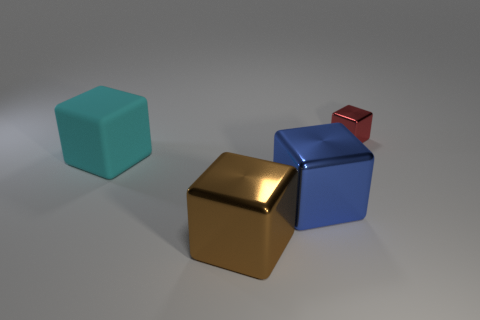Subtract all large cyan rubber blocks. How many blocks are left? 3 Add 4 big cyan cubes. How many objects exist? 8 Subtract all red blocks. How many blocks are left? 3 Subtract all purple cubes. Subtract all purple balls. How many cubes are left? 4 Subtract 0 cyan spheres. How many objects are left? 4 Subtract all yellow matte cylinders. Subtract all small red metallic objects. How many objects are left? 3 Add 3 blue shiny things. How many blue shiny things are left? 4 Add 2 red cylinders. How many red cylinders exist? 2 